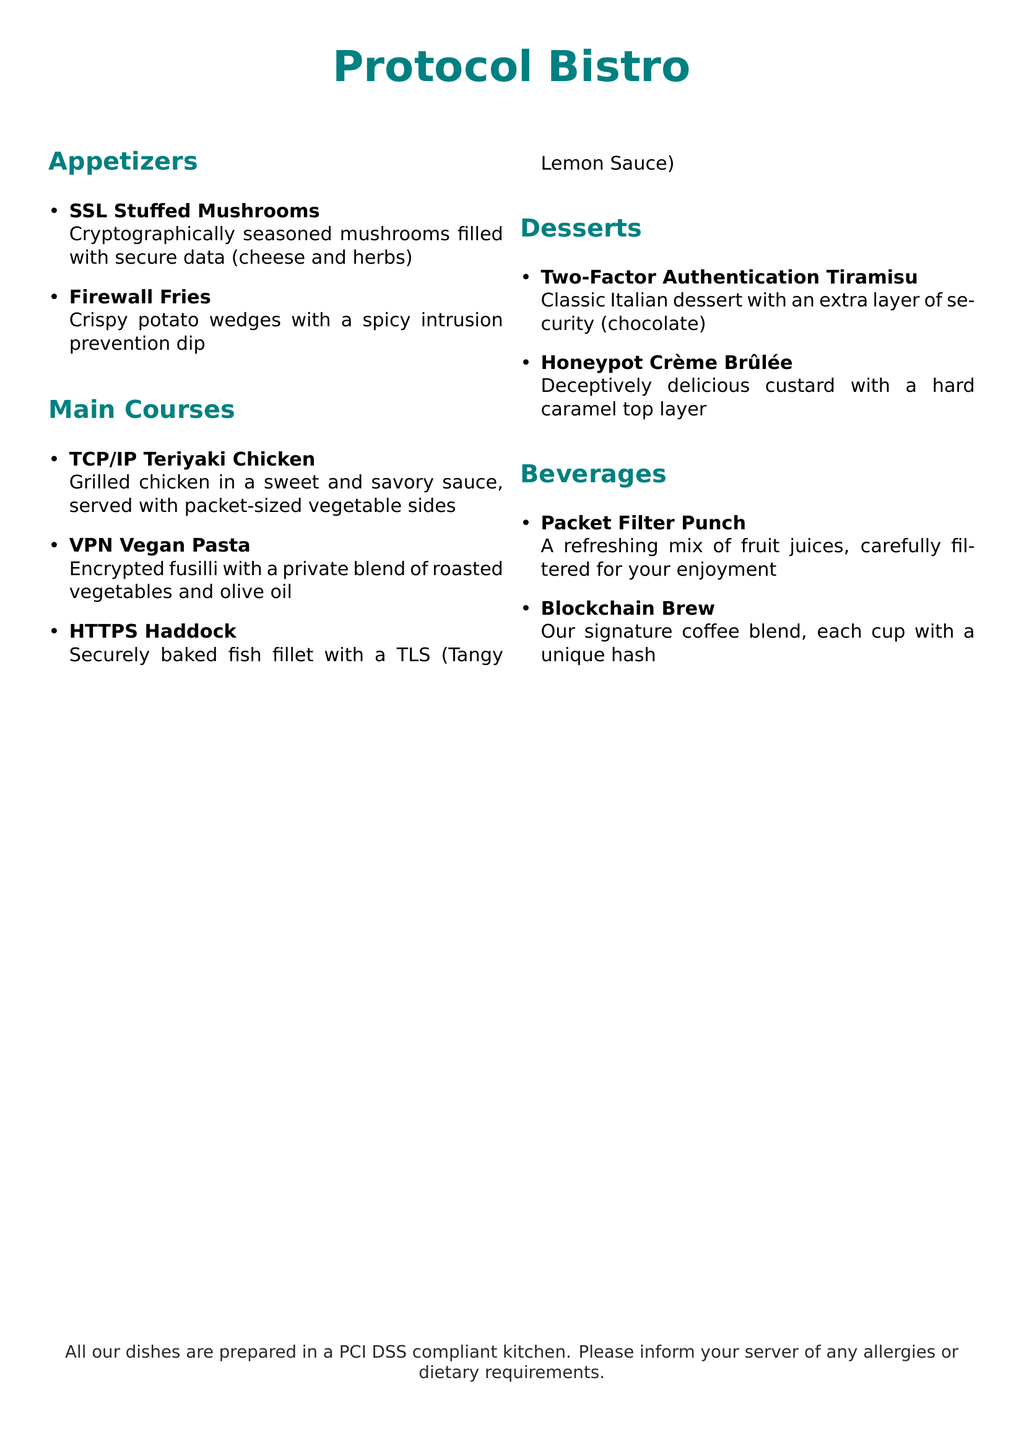What is the name of the restaurant? The name of the restaurant is featured prominently at the top of the menu.
Answer: Protocol Bistro How many appetizers are listed? The menu lists appetizers in a specific section, and the number of items can be counted.
Answer: 2 What is the main ingredient in the VPN Vegan Pasta? The description of the dish mentions the main ingredient as part of its title.
Answer: Roasted vegetables What sauce accompanies the HTTPS Haddock? The dish's description specifies the accompanying sauce.
Answer: Tangy Lemon Sauce What dessert includes chocolate? The description of the dessert directly mentions the ingredient.
Answer: Two-Factor Authentication Tiramisu What is the first beverage listed on the menu? The beverages section lists them in order, starting with the first item.
Answer: Packet Filter Punch What type of chicken is served in the main courses? The dish's name identifies the type of meat used in the recipe.
Answer: Teriyaki Chicken What is mentioned about the kitchen preparation? A disclaimer at the bottom of the menu informs about kitchen standards.
Answer: PCI DSS compliant What is the unique feature of the Blockchain Brew? The description specifies a particular characteristic of the beverage.
Answer: Unique hash 